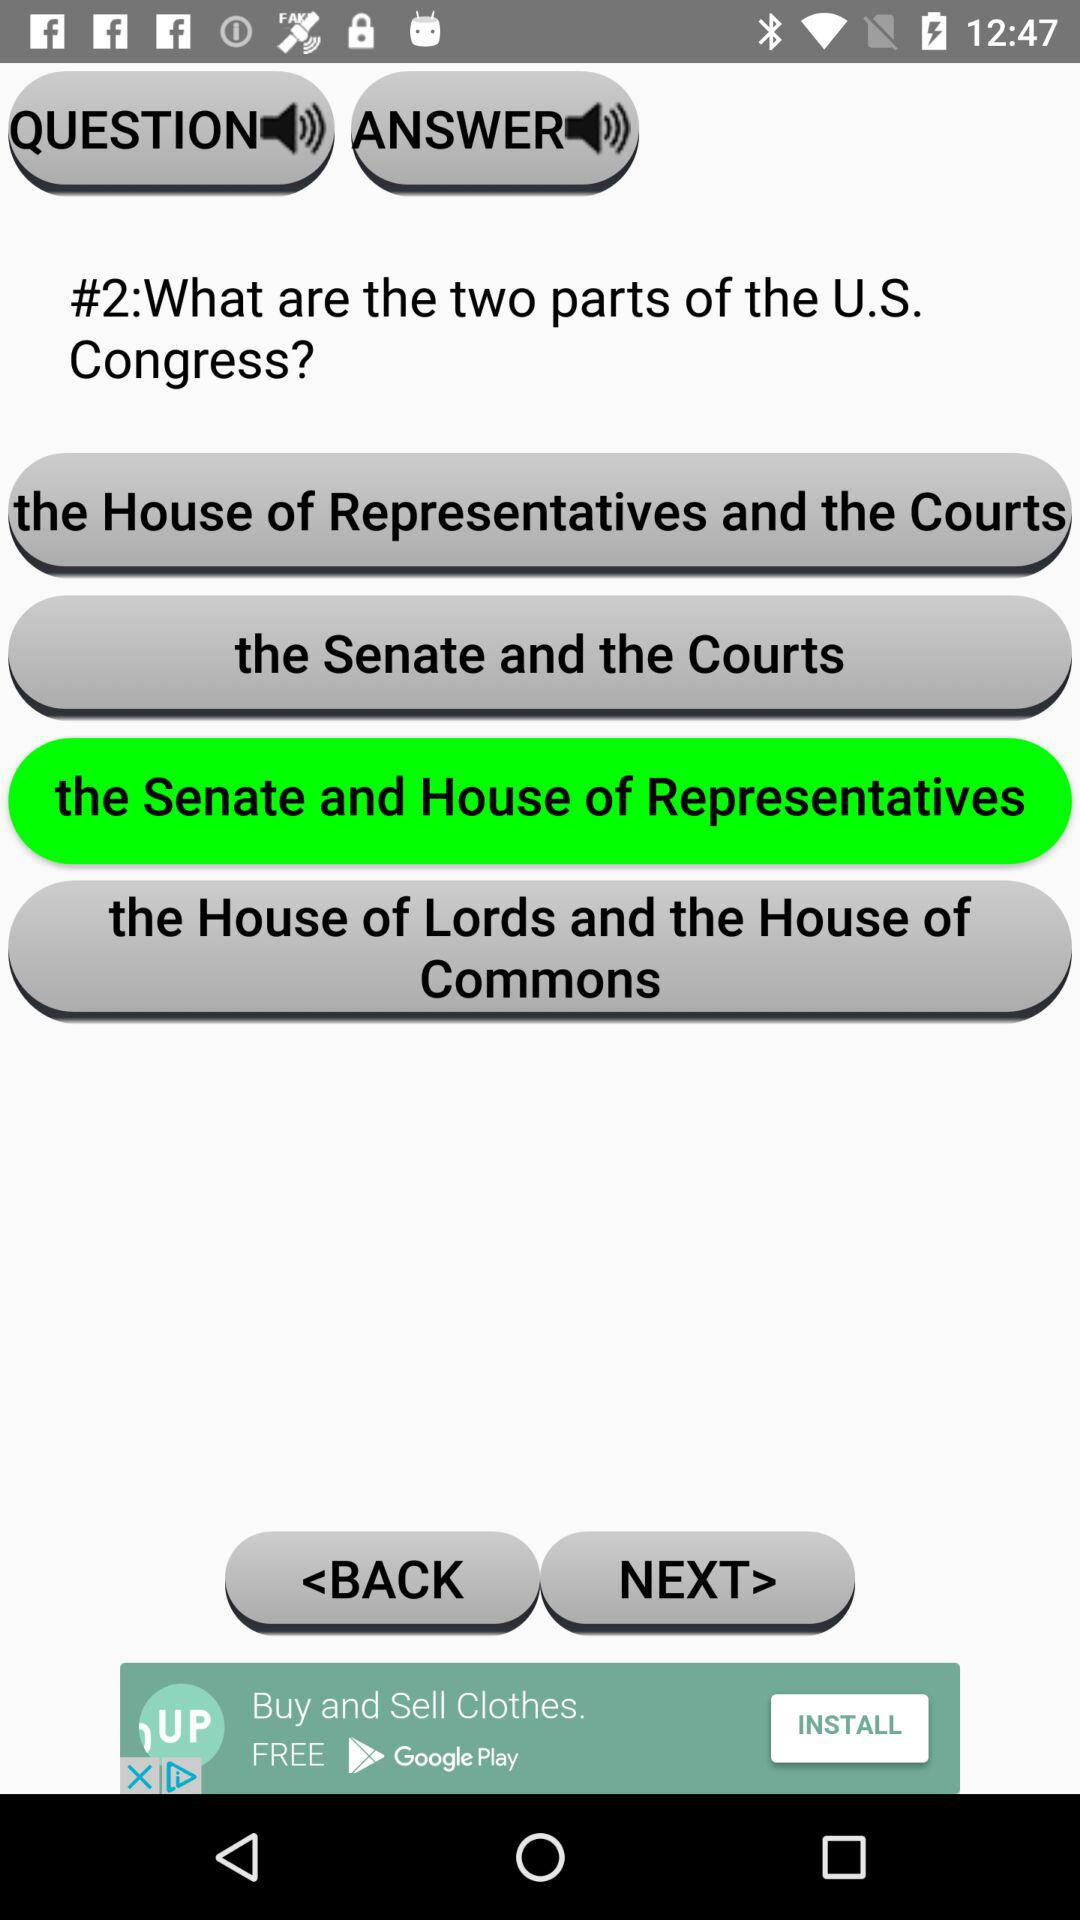How many parts are there to the US Congress?
Answer the question using a single word or phrase. 2 